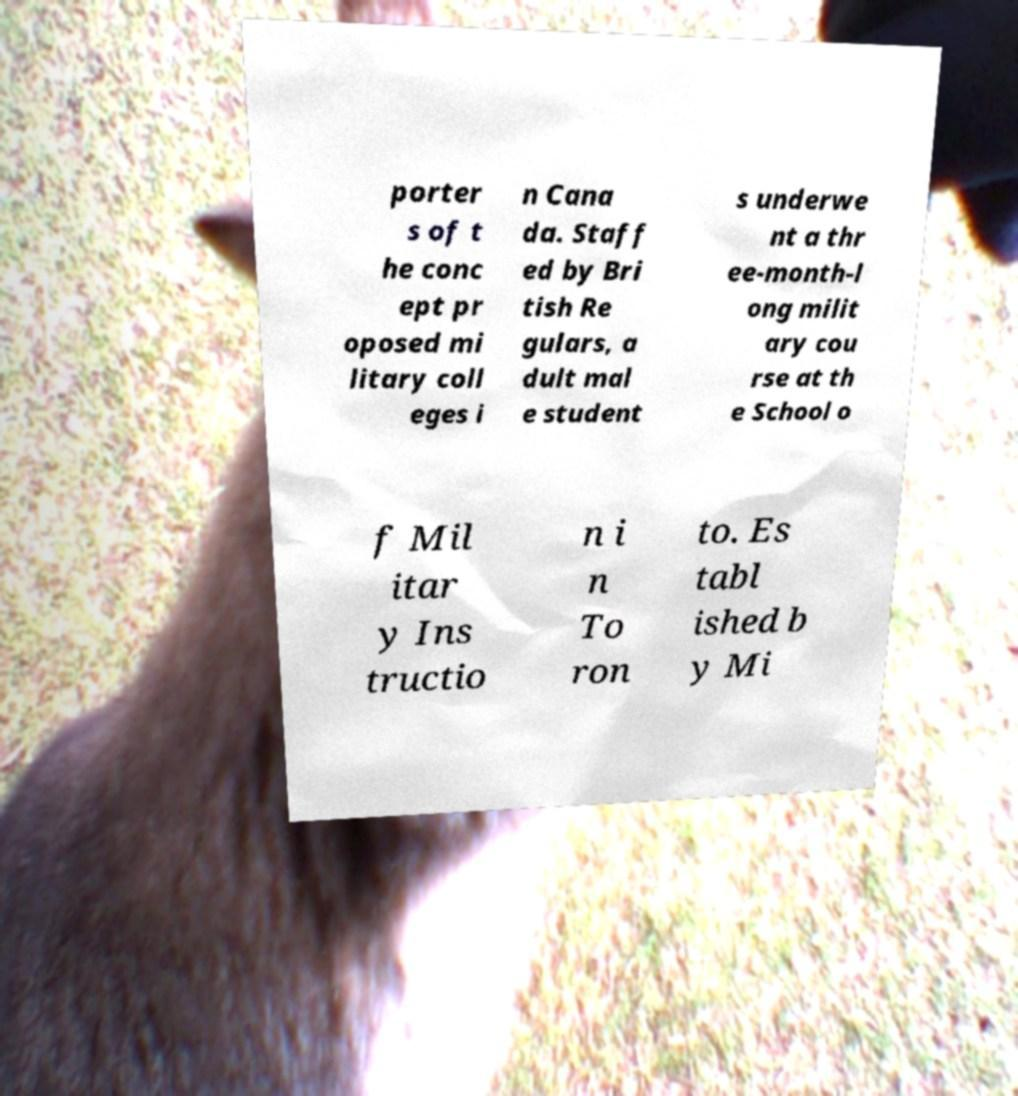Could you extract and type out the text from this image? porter s of t he conc ept pr oposed mi litary coll eges i n Cana da. Staff ed by Bri tish Re gulars, a dult mal e student s underwe nt a thr ee-month-l ong milit ary cou rse at th e School o f Mil itar y Ins tructio n i n To ron to. Es tabl ished b y Mi 